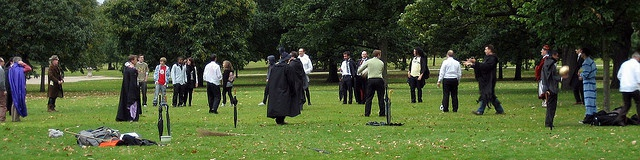Describe the objects in this image and their specific colors. I can see people in black, gray, olive, and darkgreen tones, people in black, darkgreen, gray, and olive tones, people in black, gray, and darkgreen tones, people in black, white, lightblue, and gray tones, and people in black, darkgray, gray, and beige tones in this image. 